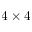<formula> <loc_0><loc_0><loc_500><loc_500>4 \times 4</formula> 